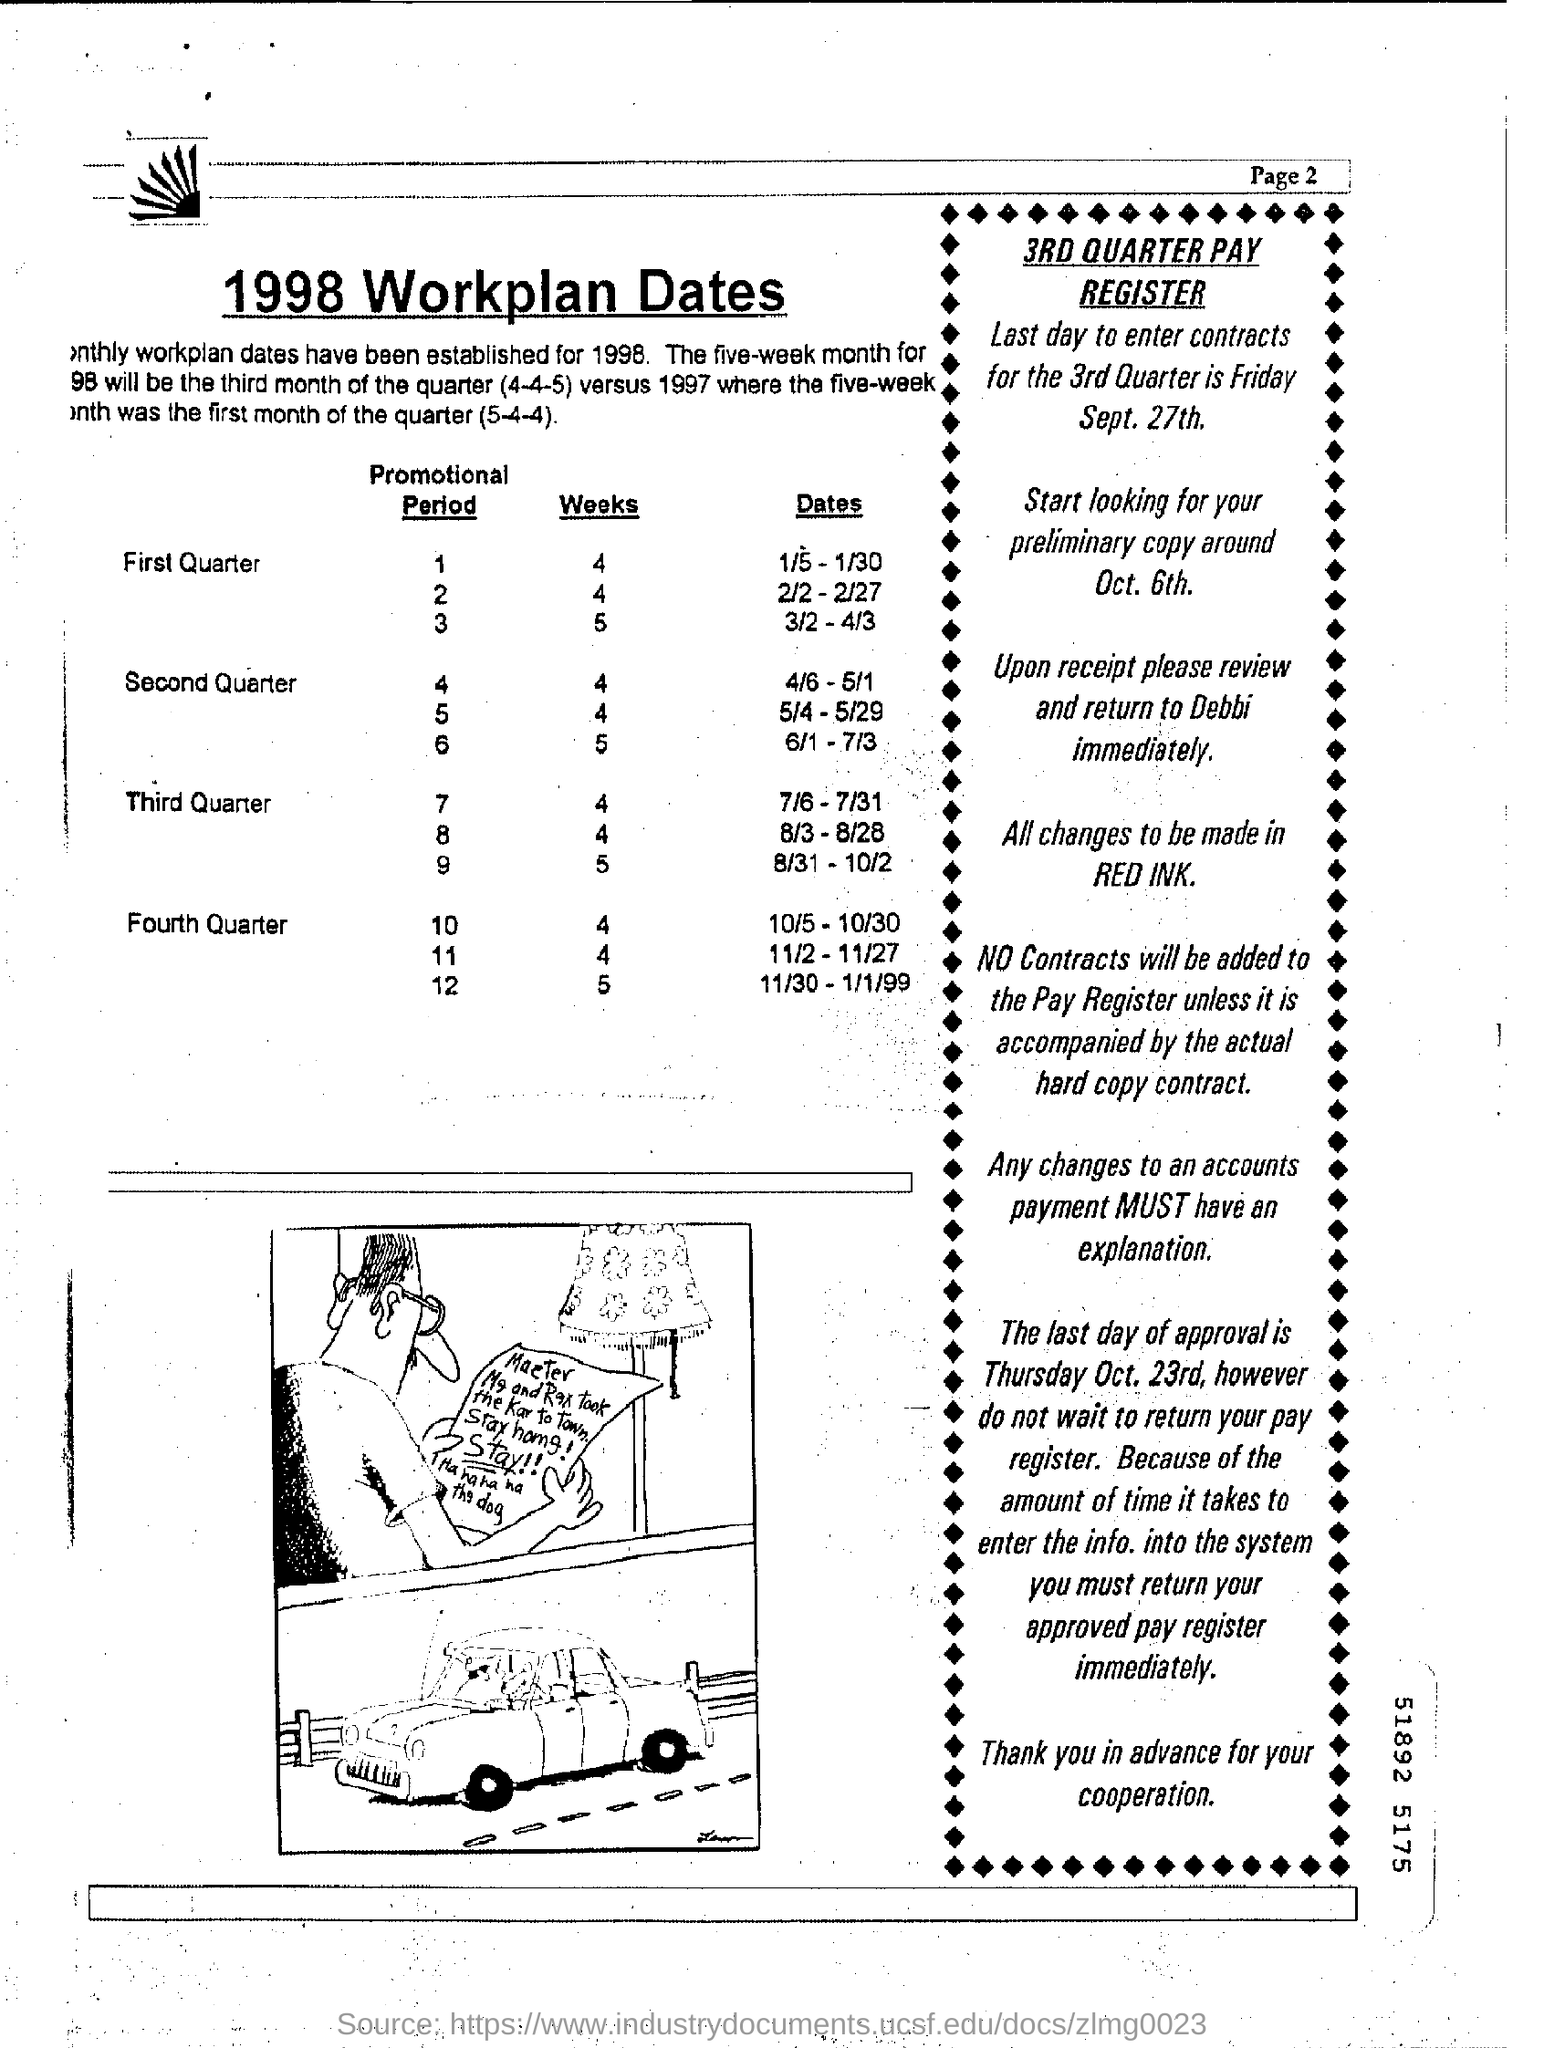What is the last day to enter contracts for the 3rd quarter ?
Offer a terse response. Friday Sept. 27th. What is the last day of approval?
Your answer should be very brief. Thursday Oct. 23rd. 